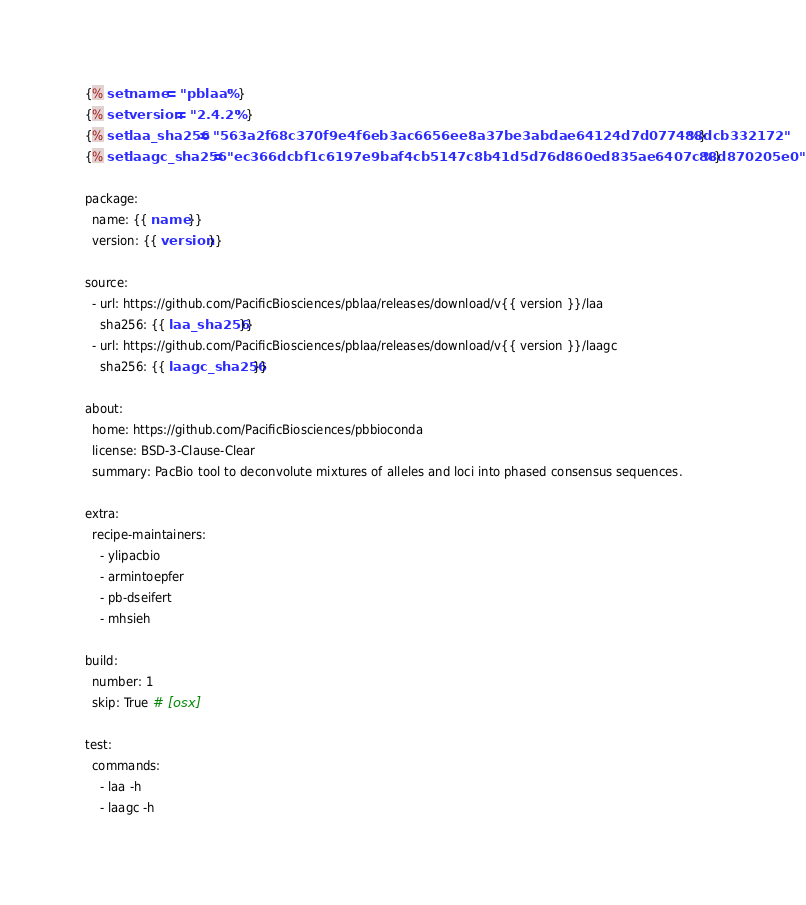<code> <loc_0><loc_0><loc_500><loc_500><_YAML_>{% set name = "pblaa" %}
{% set version = "2.4.2" %}
{% set laa_sha256 = "563a2f68c370f9e4f6eb3ac6656ee8a37be3abdae64124d7d077488dcb332172" %}
{% set laagc_sha256 = "ec366dcbf1c6197e9baf4cb5147c8b41d5d76d860ed835ae6407c88d870205e0" %}

package:
  name: {{ name }}
  version: {{ version }}

source:
  - url: https://github.com/PacificBiosciences/pblaa/releases/download/v{{ version }}/laa
    sha256: {{ laa_sha256 }}
  - url: https://github.com/PacificBiosciences/pblaa/releases/download/v{{ version }}/laagc
    sha256: {{ laagc_sha256 }}

about:
  home: https://github.com/PacificBiosciences/pbbioconda
  license: BSD-3-Clause-Clear
  summary: PacBio tool to deconvolute mixtures of alleles and loci into phased consensus sequences.

extra:
  recipe-maintainers:
    - ylipacbio
    - armintoepfer
    - pb-dseifert
    - mhsieh

build:
  number: 1
  skip: True # [osx]

test:
  commands:
    - laa -h
    - laagc -h
</code> 